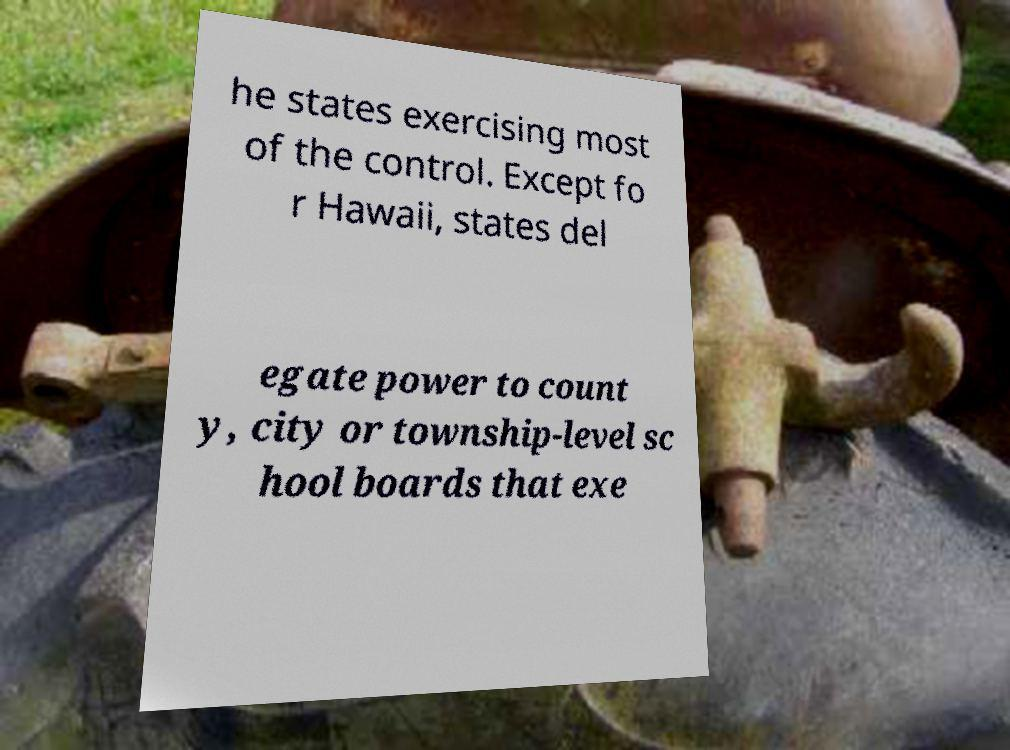For documentation purposes, I need the text within this image transcribed. Could you provide that? he states exercising most of the control. Except fo r Hawaii, states del egate power to count y, city or township-level sc hool boards that exe 